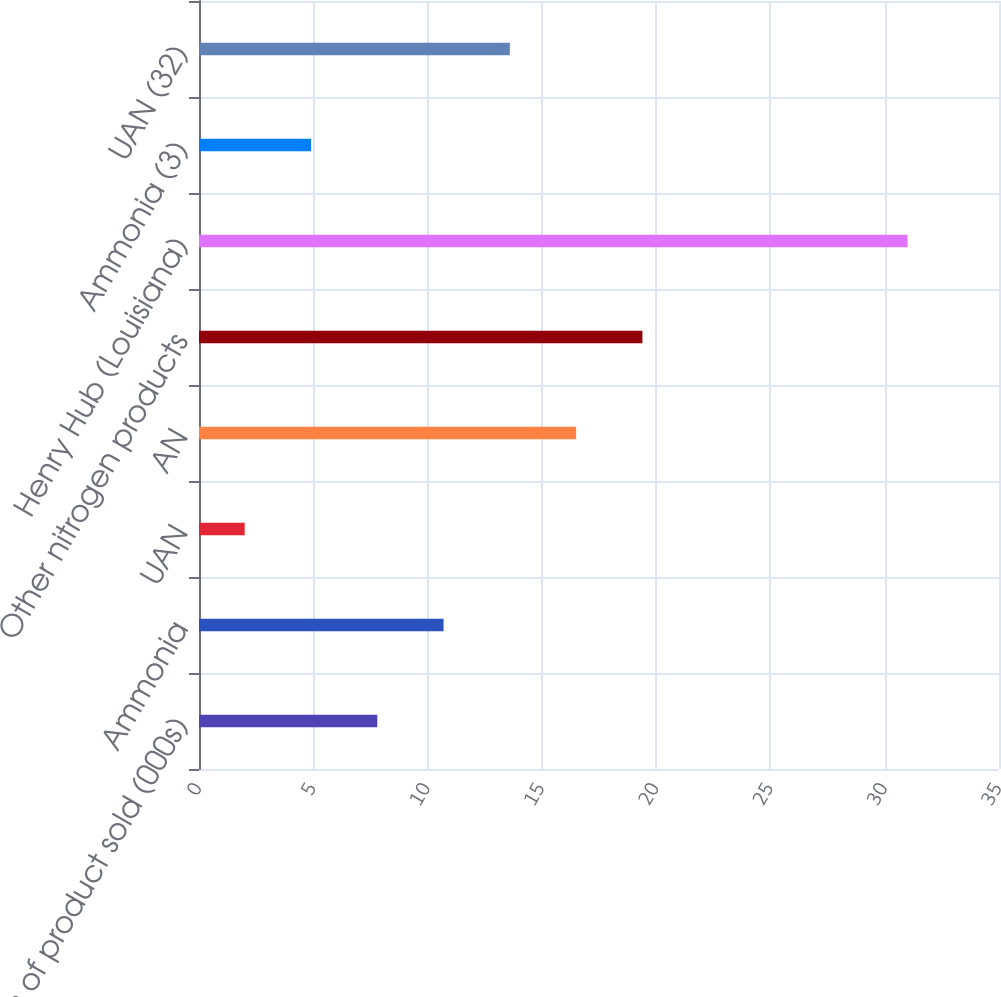Convert chart. <chart><loc_0><loc_0><loc_500><loc_500><bar_chart><fcel>Tons of product sold (000s)<fcel>Ammonia<fcel>UAN<fcel>AN<fcel>Other nitrogen products<fcel>Henry Hub (Louisiana)<fcel>Ammonia (3)<fcel>UAN (32)<nl><fcel>7.8<fcel>10.7<fcel>2<fcel>16.5<fcel>19.4<fcel>31<fcel>4.9<fcel>13.6<nl></chart> 